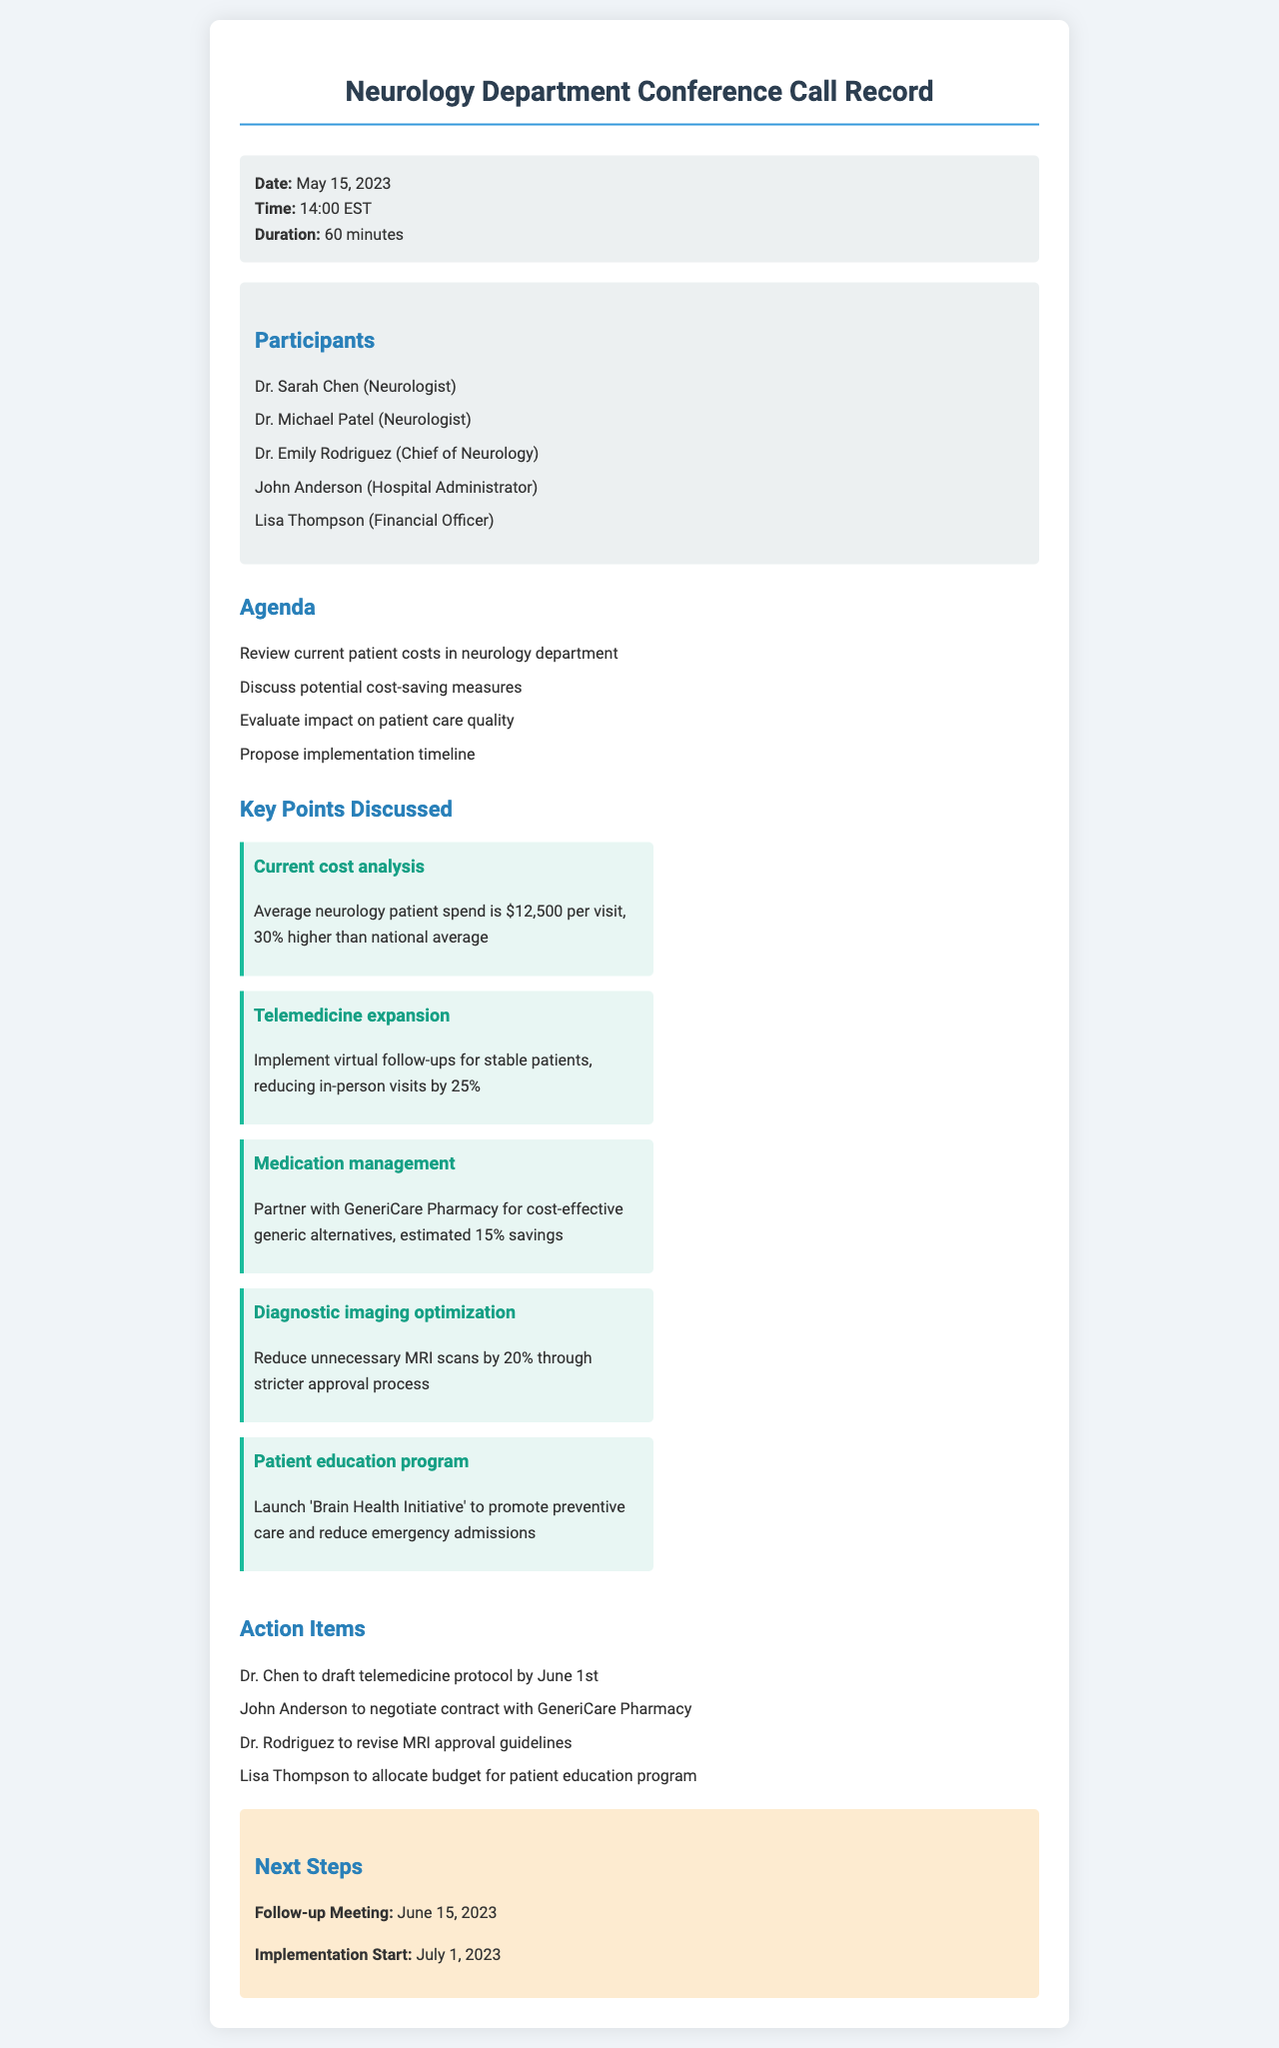What is the average neurology patient spend? The document states that the average neurology patient spend is $12,500 per visit.
Answer: $12,500 Who is the financial officer present in the call? Lisa Thompson is listed as the financial officer among the participants in the conference call.
Answer: Lisa Thompson What is the proposed implementation start date for discussed measures? The document notes that the implementation start date is set for July 1, 2023.
Answer: July 1, 2023 Which program was proposed to promote preventive care? The 'Brain Health Initiative' is mentioned as a program to promote preventive care.
Answer: Brain Health Initiative What percentage reduction in in-person visits is expected from telemedicine expansion? The discussion suggests a reduction of in-person visits by 25% through telemedicine expansion.
Answer: 25% Who is responsible for drafting the telemedicine protocol? Dr. Chen is assigned to draft the telemedicine protocol by June 1st.
Answer: Dr. Chen What impact is expected from partnering with GeneriCare Pharmacy? The estimated savings from partnering with GeneriCare Pharmacy is 15% on medication costs.
Answer: 15% What is the duration of the conference call? The document indicates that the duration of the conference call was 60 minutes.
Answer: 60 minutes When is the follow-up meeting scheduled? The follow-up meeting is scheduled for June 15, 2023.
Answer: June 15, 2023 